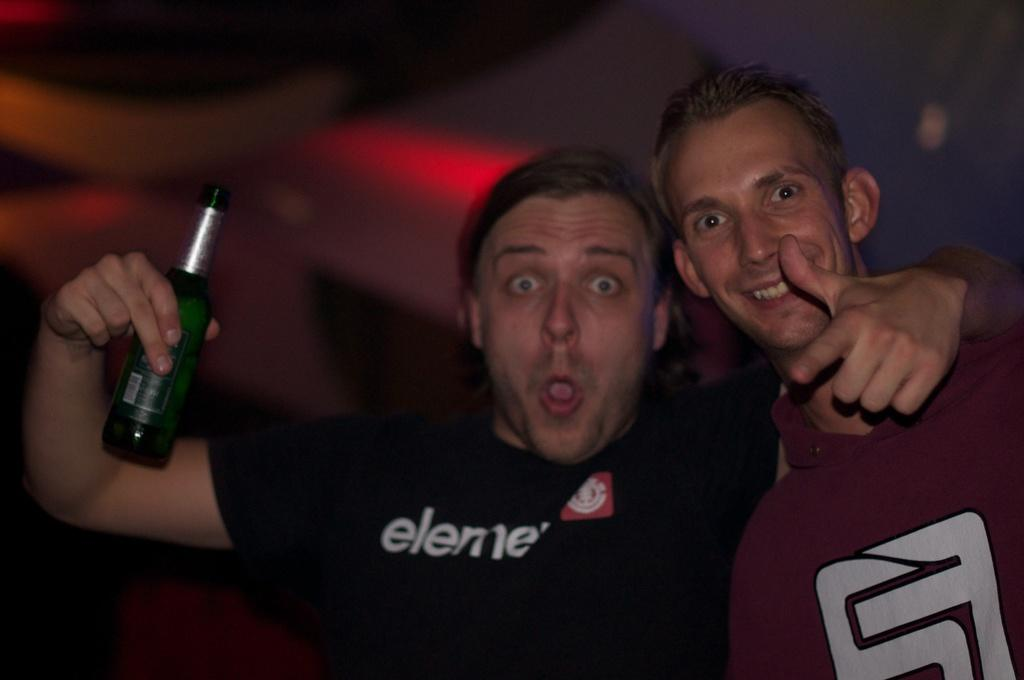How many people are in the image? There are two persons in the image. Can you describe one of the persons? One of the persons is a man, and he is wearing a black t-shirt. What is the man holding in the image? The man is holding a bottle. What can be seen in the background of the image? There is a wall in the background of the image. What type of bread can be seen on the wall in the image? There is no bread present on the wall in the image. Is the man in the image writing a message on the bottle? There is no indication in the image that the man is writing on the bottle. --- Facts: 1. There is a car in the image. 2. The car is red. 3. The car has four wheels. 4. There is a road in the image. 5. The road is paved. Absurd Topics: bird, ocean, mountain Conversation: What is the main subject of the image? The main subject of the image is a car. Can you describe the car in the image? The car is red and has four wheels. What can be seen in the background of the image? There is a road in the image. How is the road in the image constructed? The road is paved. Reasoning: Let's think step by step in order to produce the conversation. We start by identifying the main subject of the image, which is the car. Then, we describe the car's color and the number of wheels it has. Next, we mention the background of the image, which includes a road. Finally, we describe the road's construction, which is paved. Absurd Question/Answer: Can you see any mountains in the background of the image? There are no mountains visible in the background of the image. What type of bird is perched on the car's hood in the image? There is no bird present on the car's hood in the image. 